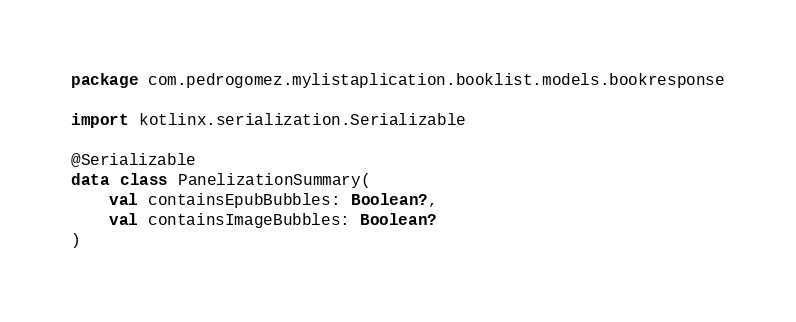Convert code to text. <code><loc_0><loc_0><loc_500><loc_500><_Kotlin_>package com.pedrogomez.mylistaplication.booklist.models.bookresponse

import kotlinx.serialization.Serializable

@Serializable
data class PanelizationSummary(
    val containsEpubBubbles: Boolean?,
    val containsImageBubbles: Boolean?
)</code> 